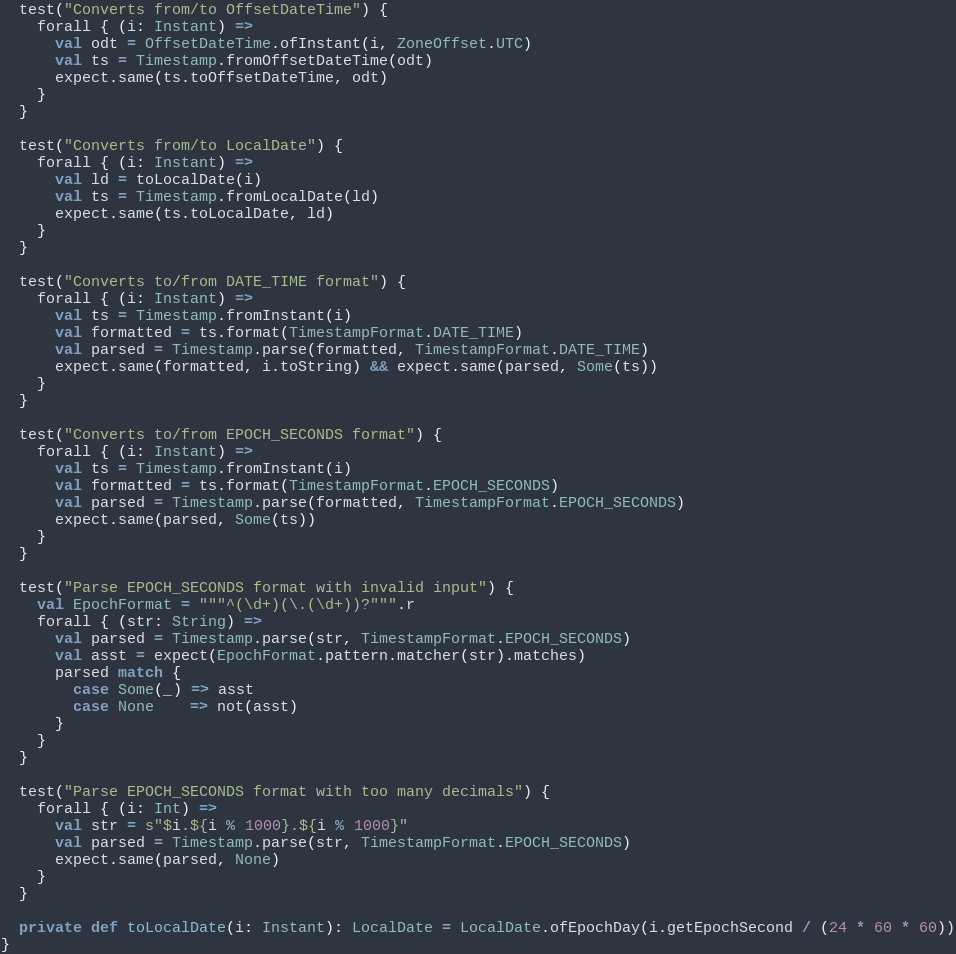<code> <loc_0><loc_0><loc_500><loc_500><_Scala_>  test("Converts from/to OffsetDateTime") {
    forall { (i: Instant) =>
      val odt = OffsetDateTime.ofInstant(i, ZoneOffset.UTC)
      val ts = Timestamp.fromOffsetDateTime(odt)
      expect.same(ts.toOffsetDateTime, odt)
    }
  }

  test("Converts from/to LocalDate") {
    forall { (i: Instant) =>
      val ld = toLocalDate(i)
      val ts = Timestamp.fromLocalDate(ld)
      expect.same(ts.toLocalDate, ld)
    }
  }

  test("Converts to/from DATE_TIME format") {
    forall { (i: Instant) =>
      val ts = Timestamp.fromInstant(i)
      val formatted = ts.format(TimestampFormat.DATE_TIME)
      val parsed = Timestamp.parse(formatted, TimestampFormat.DATE_TIME)
      expect.same(formatted, i.toString) && expect.same(parsed, Some(ts))
    }
  }

  test("Converts to/from EPOCH_SECONDS format") {
    forall { (i: Instant) =>
      val ts = Timestamp.fromInstant(i)
      val formatted = ts.format(TimestampFormat.EPOCH_SECONDS)
      val parsed = Timestamp.parse(formatted, TimestampFormat.EPOCH_SECONDS)
      expect.same(parsed, Some(ts))
    }
  }

  test("Parse EPOCH_SECONDS format with invalid input") {
    val EpochFormat = """^(\d+)(\.(\d+))?""".r
    forall { (str: String) =>
      val parsed = Timestamp.parse(str, TimestampFormat.EPOCH_SECONDS)
      val asst = expect(EpochFormat.pattern.matcher(str).matches)
      parsed match {
        case Some(_) => asst
        case None    => not(asst)
      }
    }
  }

  test("Parse EPOCH_SECONDS format with too many decimals") {
    forall { (i: Int) =>
      val str = s"$i.${i % 1000}.${i % 1000}"
      val parsed = Timestamp.parse(str, TimestampFormat.EPOCH_SECONDS)
      expect.same(parsed, None)
    }
  }

  private def toLocalDate(i: Instant): LocalDate = LocalDate.ofEpochDay(i.getEpochSecond / (24 * 60 * 60))
}
</code> 